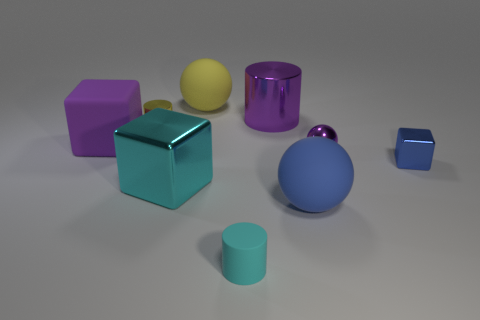Is the large metal cylinder the same color as the shiny sphere?
Ensure brevity in your answer.  Yes. Are there more small cylinders than cyan rubber things?
Provide a short and direct response. Yes. Is there any other thing of the same color as the tiny rubber object?
Ensure brevity in your answer.  Yes. Are the yellow cylinder and the blue ball made of the same material?
Make the answer very short. No. Is the number of blue spheres less than the number of large rubber things?
Give a very brief answer. Yes. Do the small blue metallic thing and the yellow metal thing have the same shape?
Make the answer very short. No. The tiny sphere has what color?
Ensure brevity in your answer.  Purple. How many other things are there of the same material as the blue sphere?
Provide a succinct answer. 3. How many yellow objects are shiny spheres or cylinders?
Make the answer very short. 1. Does the metallic thing that is to the left of the cyan metallic object have the same shape as the small rubber thing that is in front of the tiny purple ball?
Keep it short and to the point. Yes. 